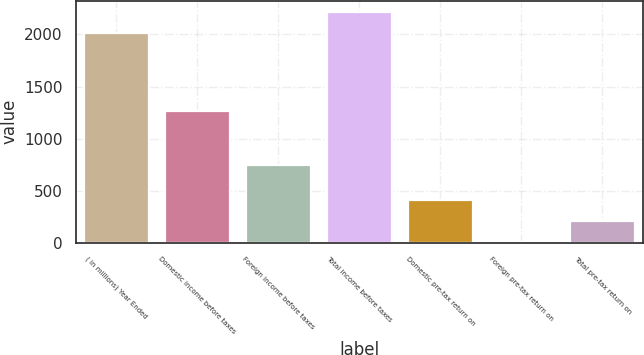<chart> <loc_0><loc_0><loc_500><loc_500><bar_chart><fcel>( in millions) Year Ended<fcel>Domestic income before taxes<fcel>Foreign income before taxes<fcel>Total income before taxes<fcel>Domestic pre-tax return on<fcel>Foreign pre-tax return on<fcel>Total pre-tax return on<nl><fcel>2014<fcel>1267.3<fcel>750.3<fcel>2214.9<fcel>410.4<fcel>8.6<fcel>209.5<nl></chart> 